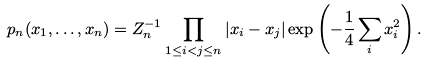<formula> <loc_0><loc_0><loc_500><loc_500>p _ { n } ( x _ { 1 } , \dots , x _ { n } ) = Z _ { n } ^ { - 1 } \prod _ { 1 \leq i < j \leq n } | x _ { i } - x _ { j } | \exp \left ( - \frac { 1 } { 4 } \sum _ { i } x _ { i } ^ { 2 } \right ) .</formula> 